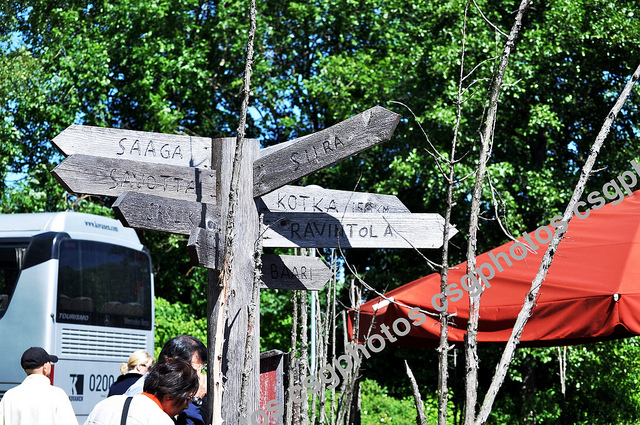Identify the text contained in this image. RAVINTOLA KOTKA SAAGA SAVOTTA BARRI csgphotos csgp csgphotos K 0200 SHAR 